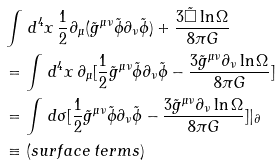Convert formula to latex. <formula><loc_0><loc_0><loc_500><loc_500>& \int \, d ^ { 4 } x \, \frac { 1 } { 2 } \partial _ { \mu } ( \tilde { g } ^ { \mu \nu } \tilde { \phi } \partial _ { \nu } \tilde { \phi } ) + \frac { 3 \tilde { \square } \ln \Omega } { 8 \pi G } \\ & = \int \, d ^ { 4 } x \, \partial _ { \mu } [ \frac { 1 } { 2 } \tilde { g } ^ { \mu \nu } \tilde { \phi } \partial _ { \nu } \tilde { \phi } - \frac { 3 \tilde { g } ^ { \mu \nu } \partial _ { \nu } \ln \Omega } { 8 \pi G } ] \\ & = \int \, d \sigma [ \frac { 1 } { 2 } \tilde { g } ^ { \mu \nu } \tilde { \phi } \partial _ { \nu } \tilde { \phi } - \frac { 3 \tilde { g } ^ { \mu \nu } \partial _ { \nu } \ln \Omega } { 8 \pi G } ] | _ { \partial } \\ & \equiv ( s u r f a c e \, t e r m s )</formula> 